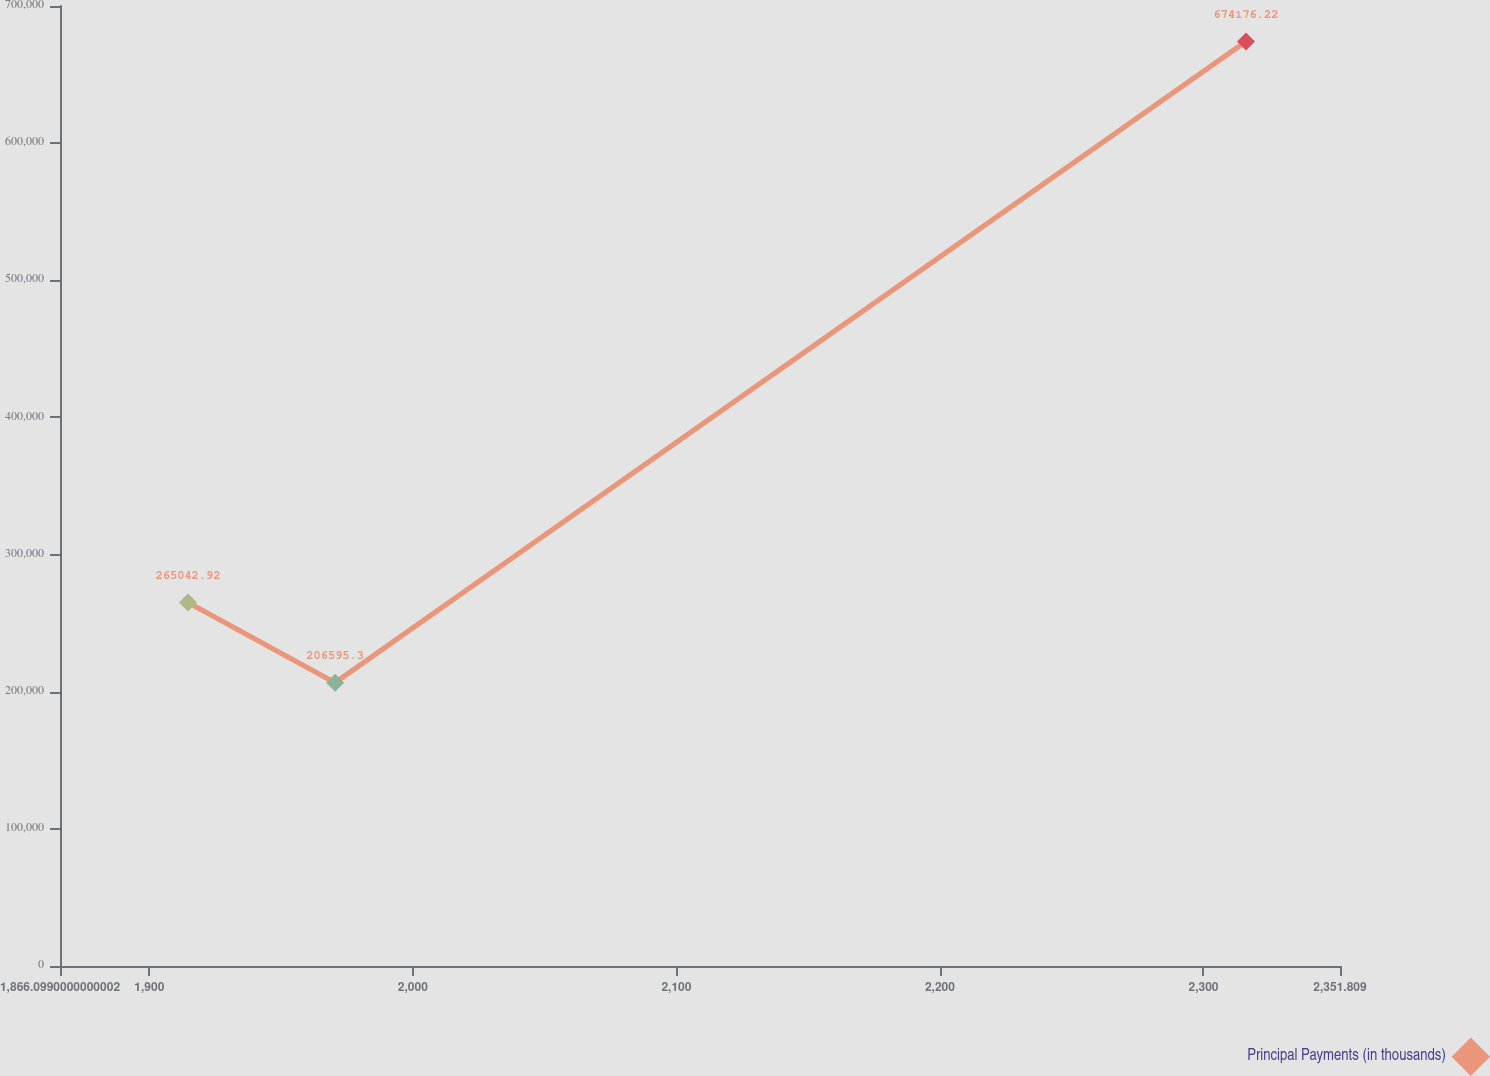Convert chart to OTSL. <chart><loc_0><loc_0><loc_500><loc_500><line_chart><ecel><fcel>Principal Payments (in thousands)<nl><fcel>1914.67<fcel>265043<nl><fcel>1970.5<fcel>206595<nl><fcel>2316.14<fcel>674176<nl><fcel>2358.26<fcel>89700.1<nl><fcel>2400.38<fcel>148148<nl></chart> 